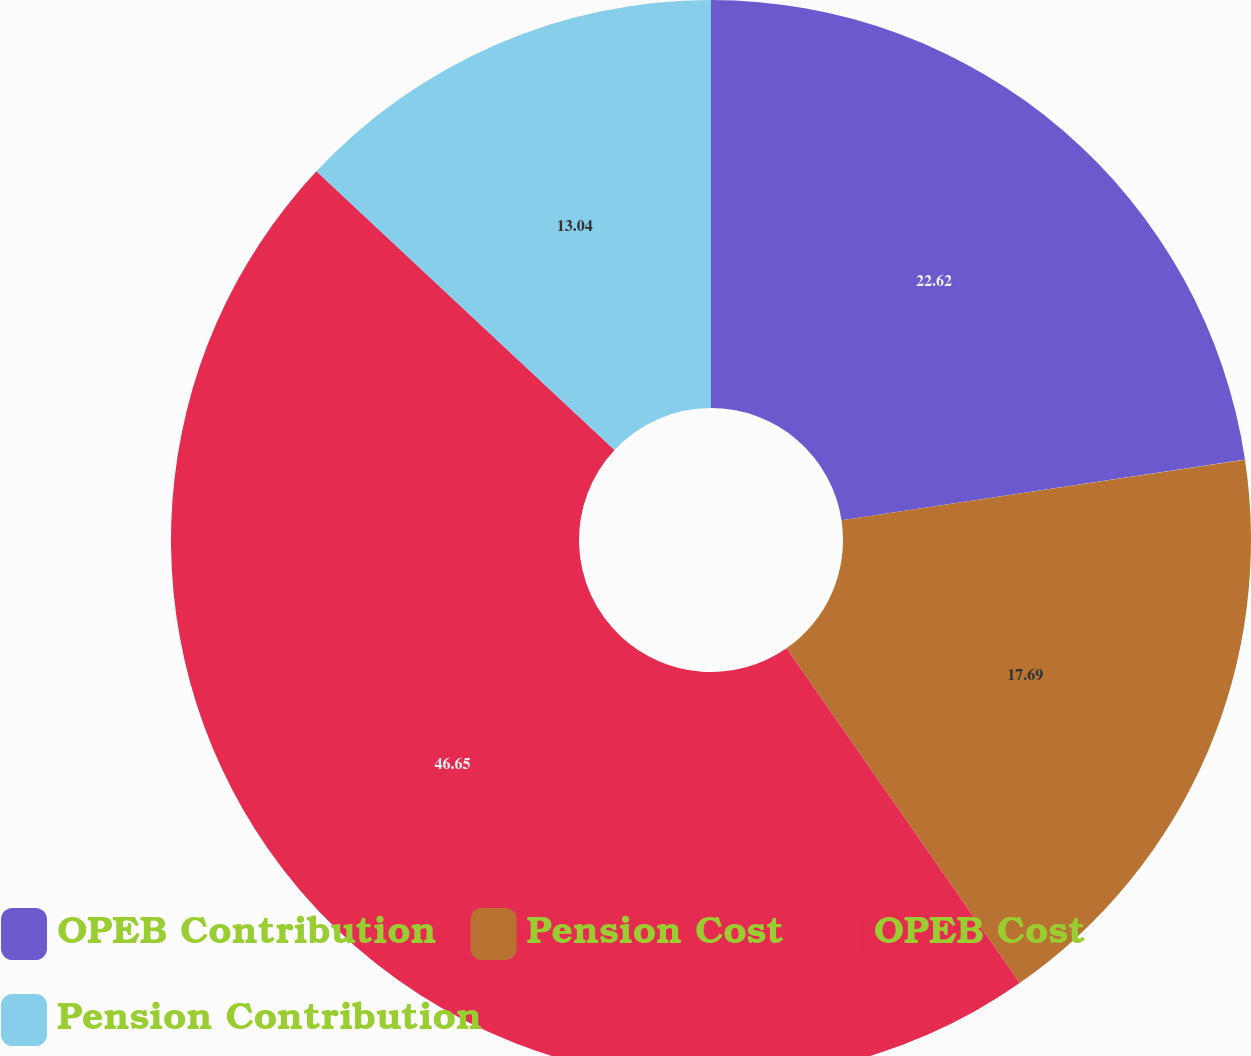Convert chart. <chart><loc_0><loc_0><loc_500><loc_500><pie_chart><fcel>OPEB Contribution<fcel>Pension Cost<fcel>OPEB Cost<fcel>Pension Contribution<nl><fcel>22.62%<fcel>17.69%<fcel>46.64%<fcel>13.04%<nl></chart> 